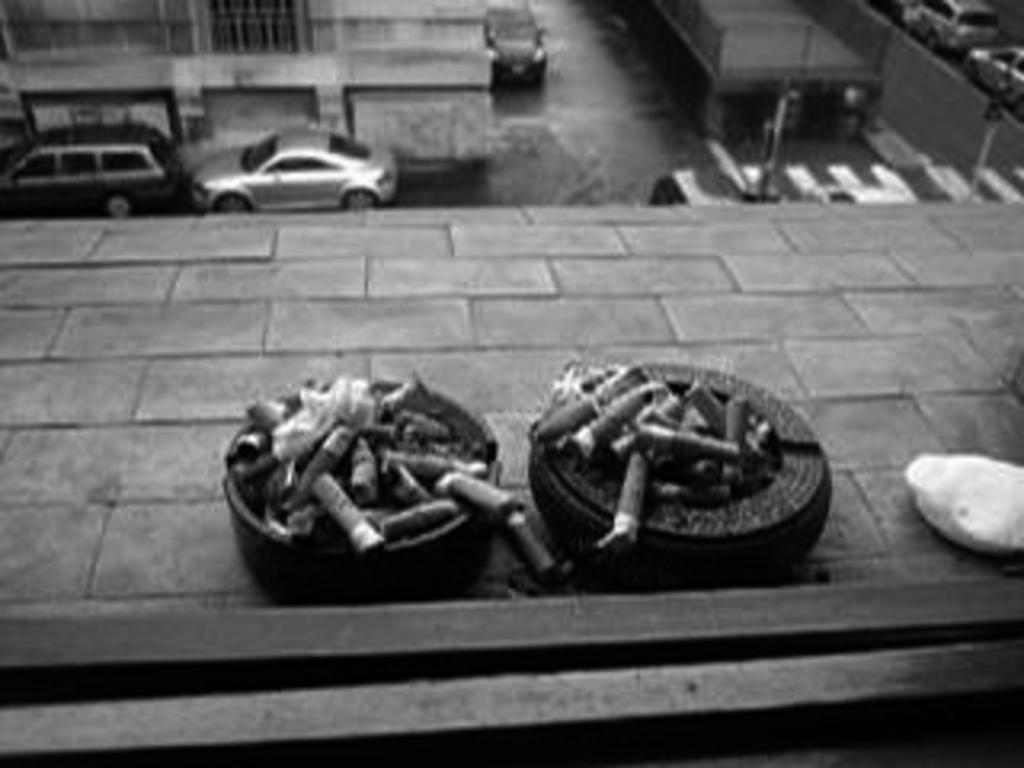What type of vehicles can be seen in the image? There are cars in the image. What structures are present in the image? There are buildings in the image. What part of the cars is visible in the image? There are tyres in the image. Can you see anyone wearing a sweater in the image? There is no mention of people or clothing in the image, so it cannot be determined if someone is wearing a sweater. 